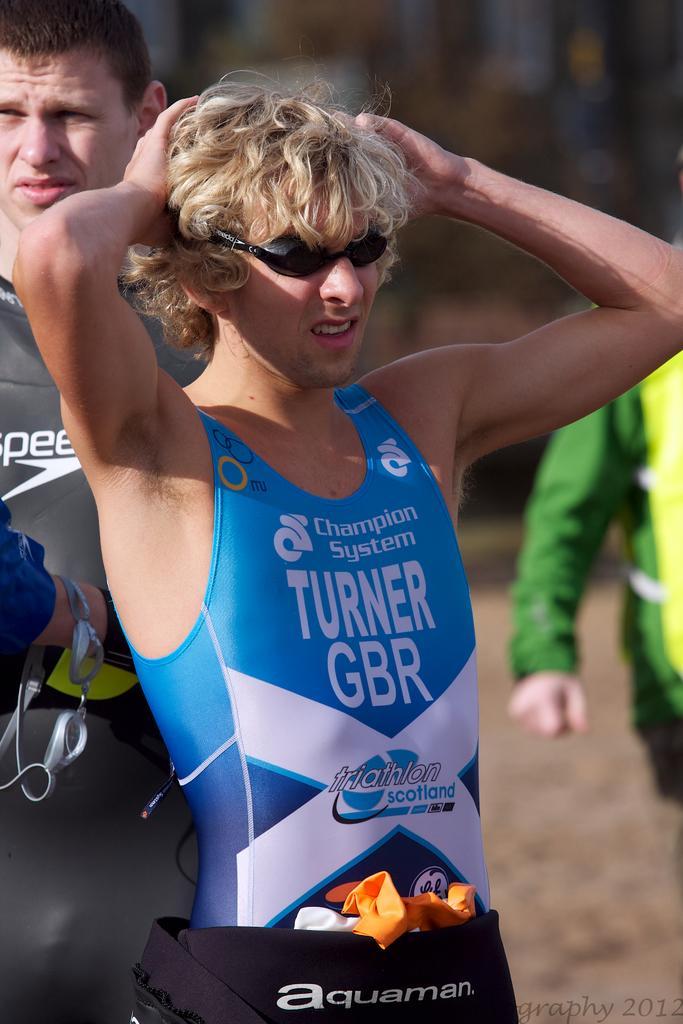Describe this image in one or two sentences. This image is taken outdoors. In the middle of the image a man is standing on the floor. On the left side of the image there is a man. On the right side of the image there is another man. 